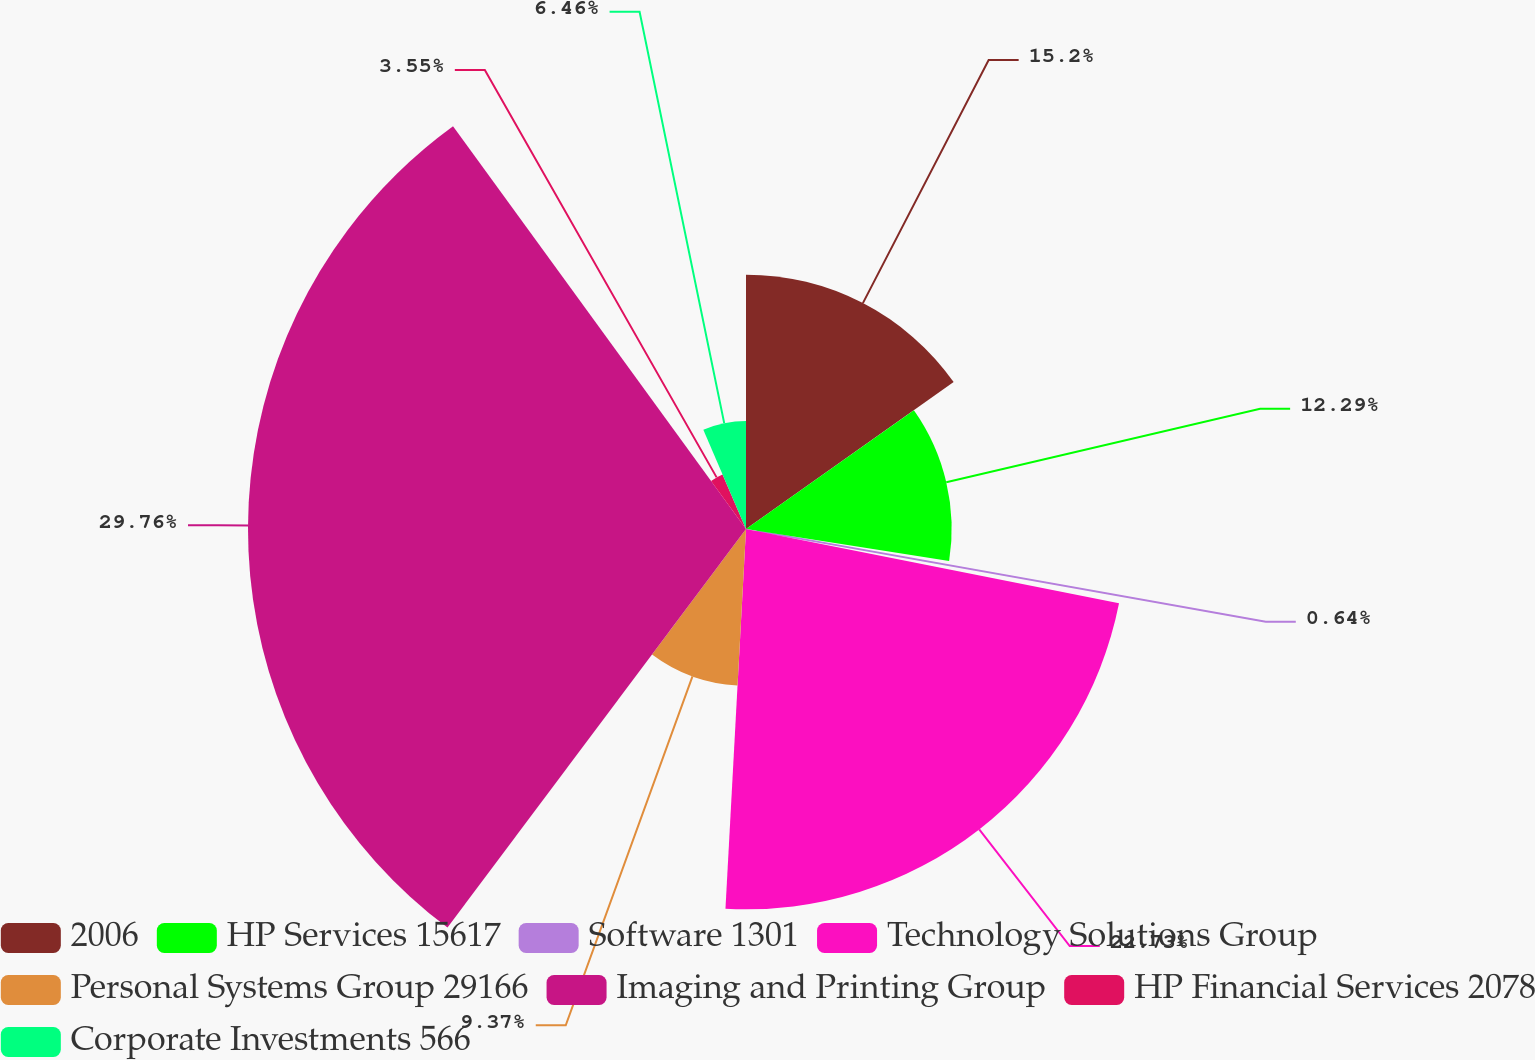Convert chart. <chart><loc_0><loc_0><loc_500><loc_500><pie_chart><fcel>2006<fcel>HP Services 15617<fcel>Software 1301<fcel>Technology Solutions Group<fcel>Personal Systems Group 29166<fcel>Imaging and Printing Group<fcel>HP Financial Services 2078<fcel>Corporate Investments 566<nl><fcel>15.2%<fcel>12.29%<fcel>0.64%<fcel>22.73%<fcel>9.37%<fcel>29.76%<fcel>3.55%<fcel>6.46%<nl></chart> 